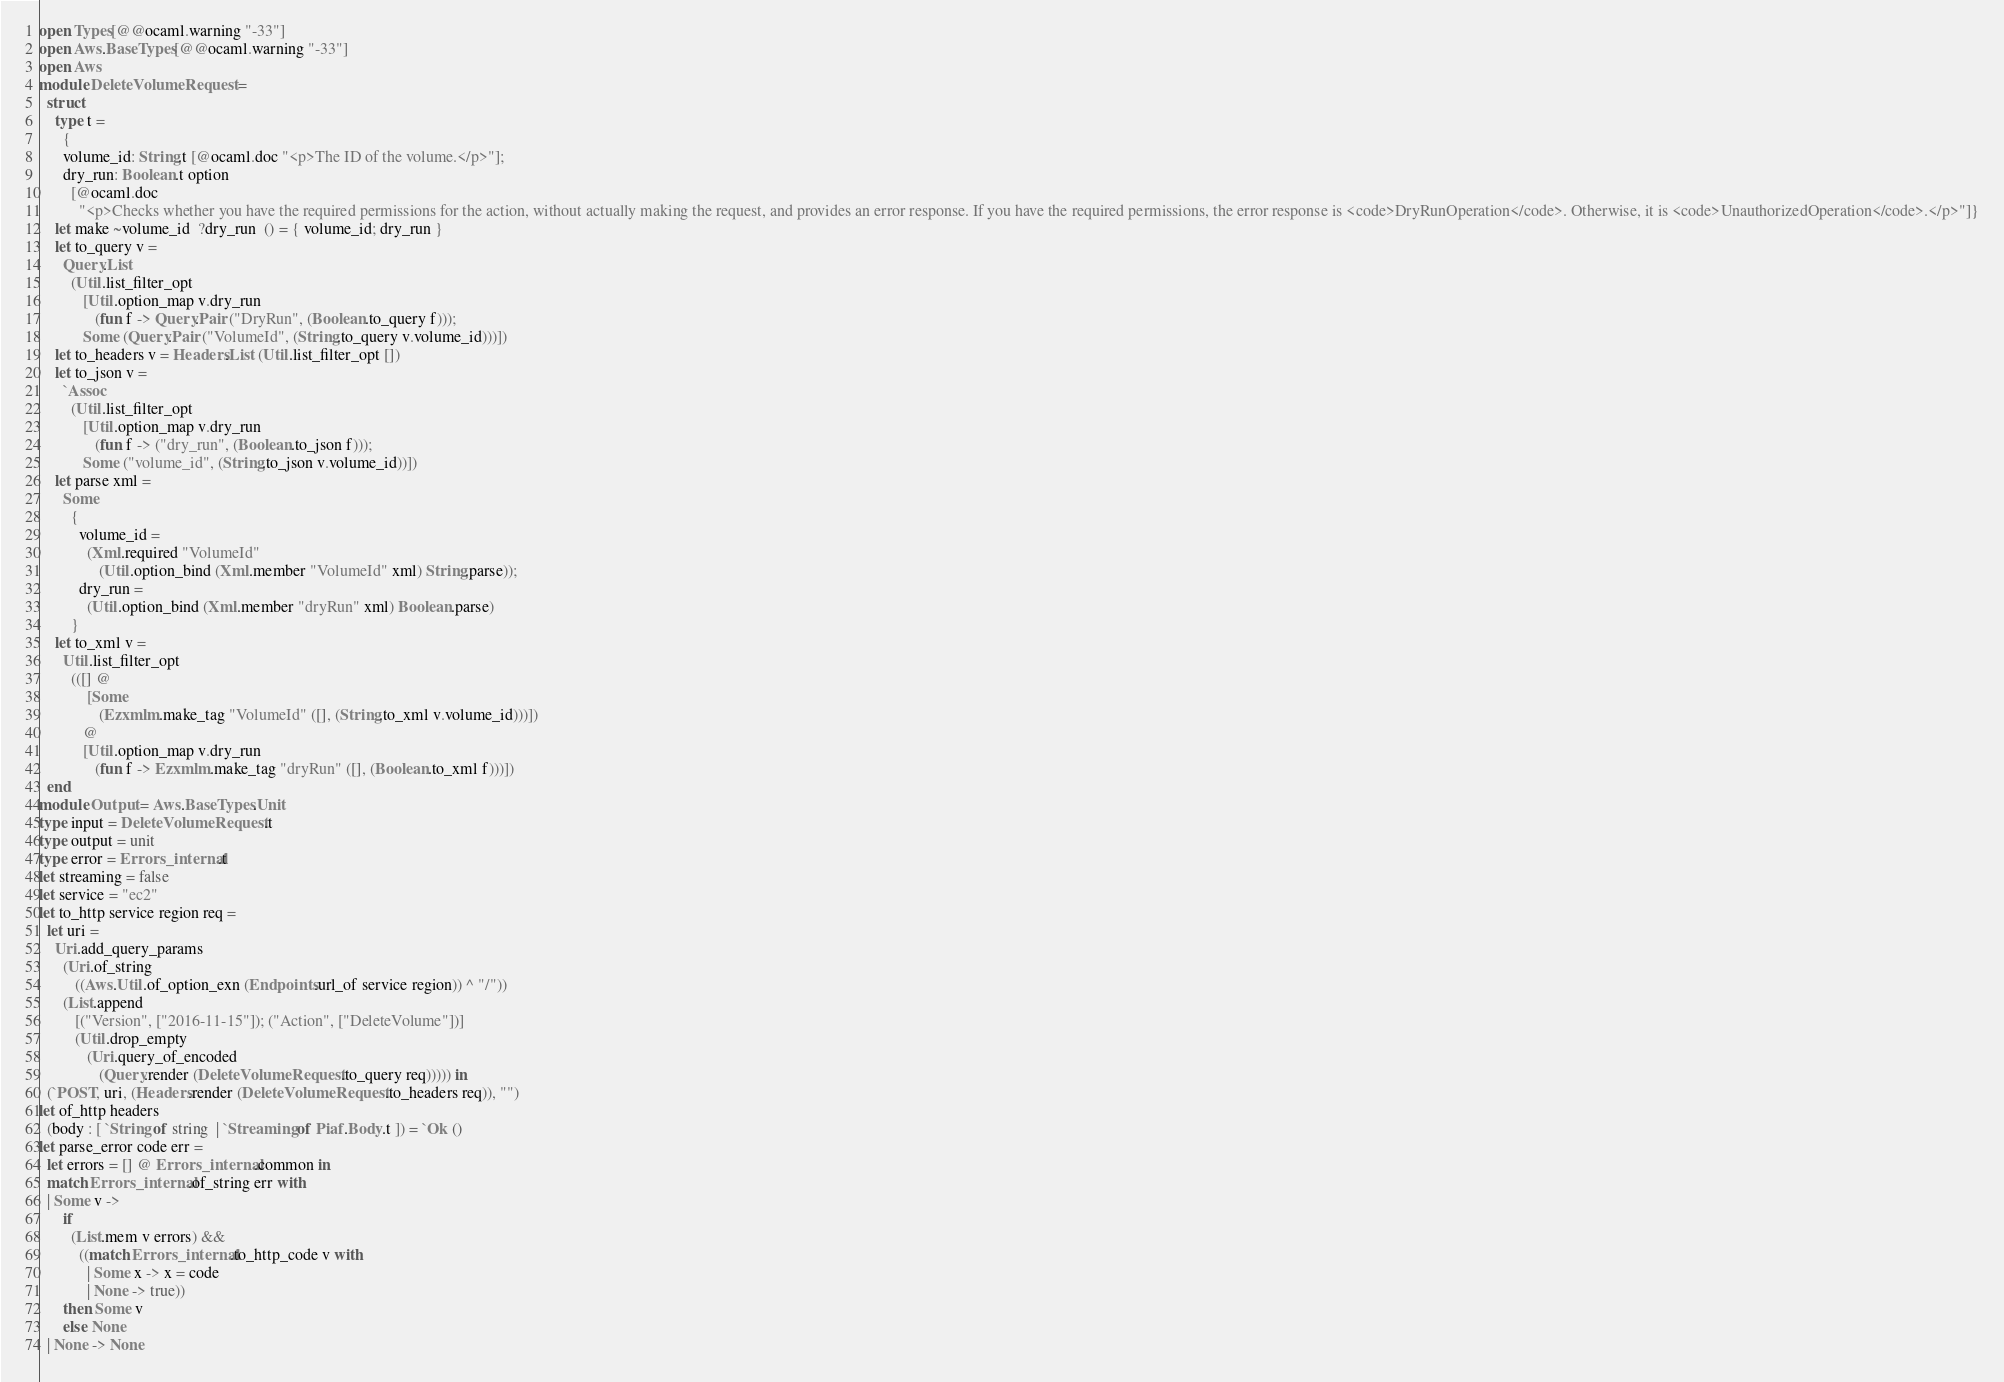<code> <loc_0><loc_0><loc_500><loc_500><_OCaml_>open Types[@@ocaml.warning "-33"]
open Aws.BaseTypes[@@ocaml.warning "-33"]
open Aws
module DeleteVolumeRequest =
  struct
    type t =
      {
      volume_id: String.t [@ocaml.doc "<p>The ID of the volume.</p>"];
      dry_run: Boolean.t option
        [@ocaml.doc
          "<p>Checks whether you have the required permissions for the action, without actually making the request, and provides an error response. If you have the required permissions, the error response is <code>DryRunOperation</code>. Otherwise, it is <code>UnauthorizedOperation</code>.</p>"]}
    let make ~volume_id  ?dry_run  () = { volume_id; dry_run }
    let to_query v =
      Query.List
        (Util.list_filter_opt
           [Util.option_map v.dry_run
              (fun f -> Query.Pair ("DryRun", (Boolean.to_query f)));
           Some (Query.Pair ("VolumeId", (String.to_query v.volume_id)))])
    let to_headers v = Headers.List (Util.list_filter_opt [])
    let to_json v =
      `Assoc
        (Util.list_filter_opt
           [Util.option_map v.dry_run
              (fun f -> ("dry_run", (Boolean.to_json f)));
           Some ("volume_id", (String.to_json v.volume_id))])
    let parse xml =
      Some
        {
          volume_id =
            (Xml.required "VolumeId"
               (Util.option_bind (Xml.member "VolumeId" xml) String.parse));
          dry_run =
            (Util.option_bind (Xml.member "dryRun" xml) Boolean.parse)
        }
    let to_xml v =
      Util.list_filter_opt
        (([] @
            [Some
               (Ezxmlm.make_tag "VolumeId" ([], (String.to_xml v.volume_id)))])
           @
           [Util.option_map v.dry_run
              (fun f -> Ezxmlm.make_tag "dryRun" ([], (Boolean.to_xml f)))])
  end
module Output = Aws.BaseTypes.Unit
type input = DeleteVolumeRequest.t
type output = unit
type error = Errors_internal.t
let streaming = false
let service = "ec2"
let to_http service region req =
  let uri =
    Uri.add_query_params
      (Uri.of_string
         ((Aws.Util.of_option_exn (Endpoints.url_of service region)) ^ "/"))
      (List.append
         [("Version", ["2016-11-15"]); ("Action", ["DeleteVolume"])]
         (Util.drop_empty
            (Uri.query_of_encoded
               (Query.render (DeleteVolumeRequest.to_query req))))) in
  (`POST, uri, (Headers.render (DeleteVolumeRequest.to_headers req)), "")
let of_http headers
  (body : [ `String of string  | `Streaming of Piaf.Body.t ]) = `Ok ()
let parse_error code err =
  let errors = [] @ Errors_internal.common in
  match Errors_internal.of_string err with
  | Some v ->
      if
        (List.mem v errors) &&
          ((match Errors_internal.to_http_code v with
            | Some x -> x = code
            | None -> true))
      then Some v
      else None
  | None -> None</code> 